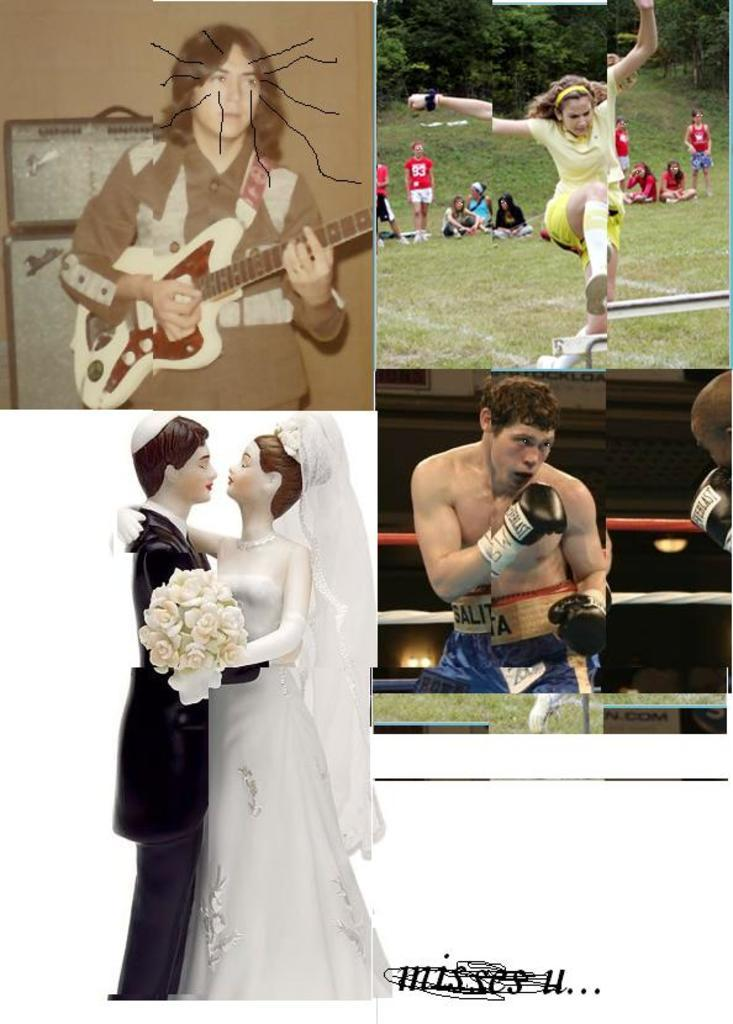What is the composition of the image? The image is a collage of four different images. Can you describe one of the images in the collage? Yes, there is a person with a guitar in one of the images. What activity is depicted in another image? There is a woman jumping in one of the images. What sport is being played in another image? There is a man boxing in one of the images. What type of doll is featured in another image? There is a couple doll in one of the images. What sound can be heard coming from the pickle in the image? There is no pickle present in the image, so no sound can be heard from it. 